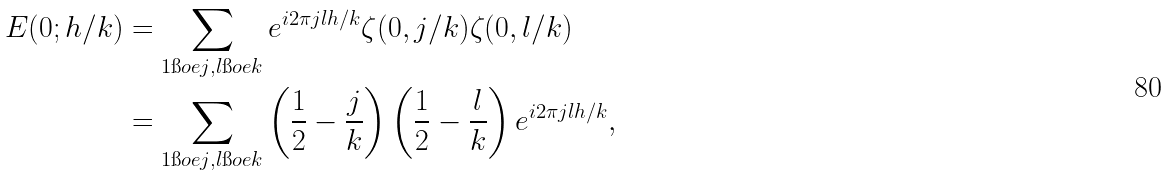Convert formula to latex. <formula><loc_0><loc_0><loc_500><loc_500>E ( 0 ; h / k ) & = \sum _ { 1 \i o e j , l \i o e k } e ^ { i 2 \pi j l h / k } \zeta ( 0 , j / k ) \zeta ( 0 , l / k ) \\ & = \sum _ { 1 \i o e j , l \i o e k } \left ( \frac { 1 } { 2 } - \frac { j } { k } \right ) \left ( \frac { 1 } { 2 } - \frac { l } { k } \right ) e ^ { i 2 \pi j l h / k } ,</formula> 